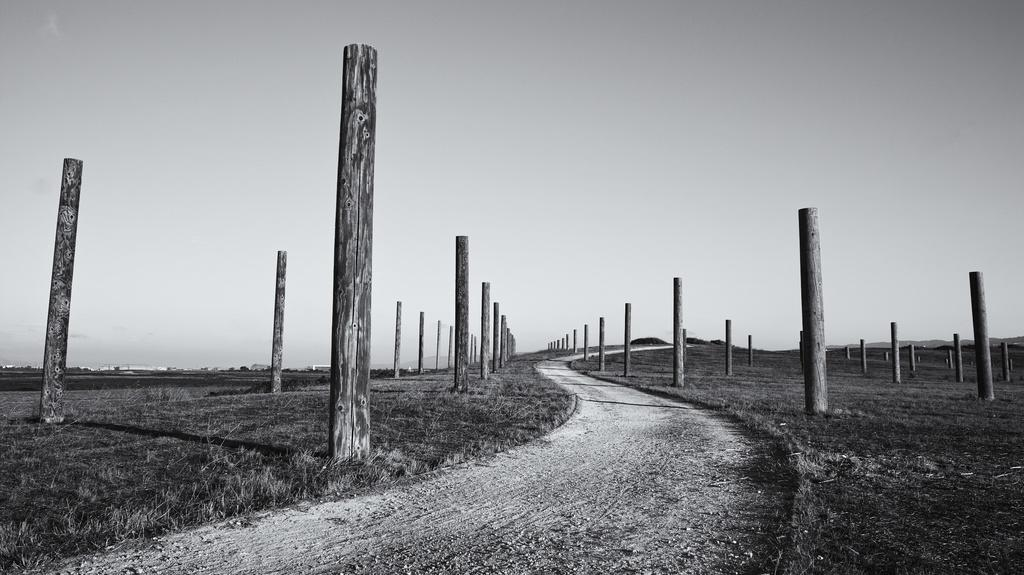What type of objects can be seen in the image? There are wooden poles in the image. What can be seen in the distance in the image? There are buildings and trees in the background of the image. What is the ground covered with in the front of the image? There is dry grass on the ground in the front of the image. What type of leg is visible in the image? There is no leg visible in the image; it only features wooden poles, buildings, trees, and dry grass. What kind of pipe can be seen connecting the wooden poles in the image? There is no pipe connecting the wooden poles in the image; the poles are separate from one another. 